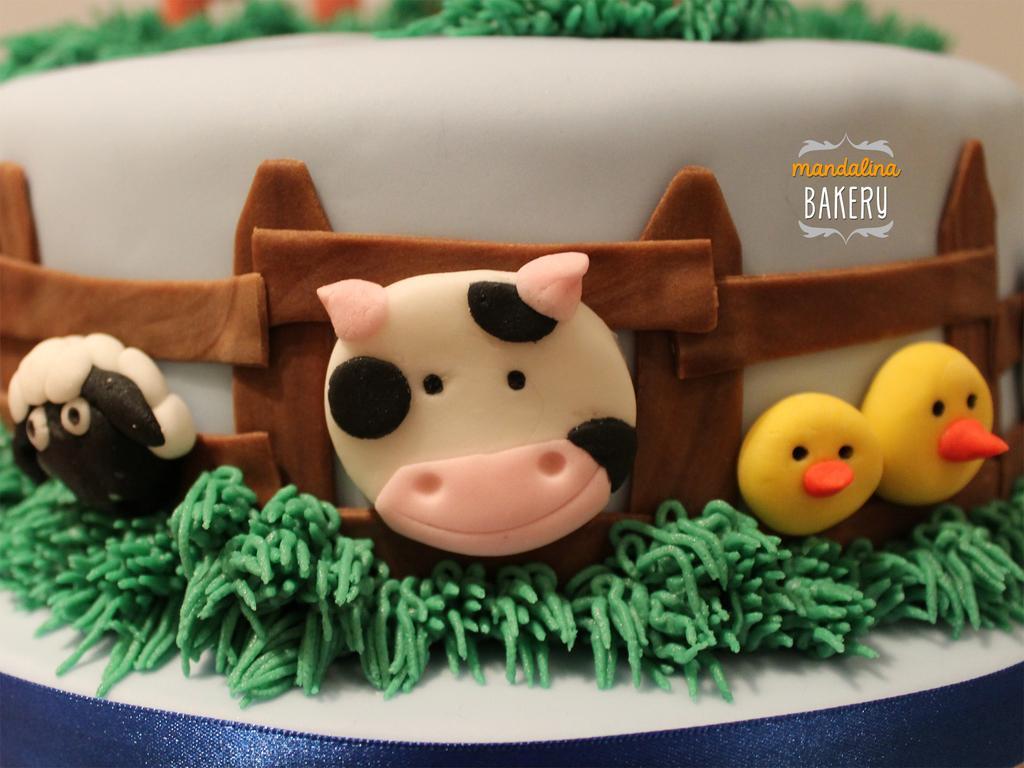In one or two sentences, can you explain what this image depicts? In this image there is a cake with cream on it. 